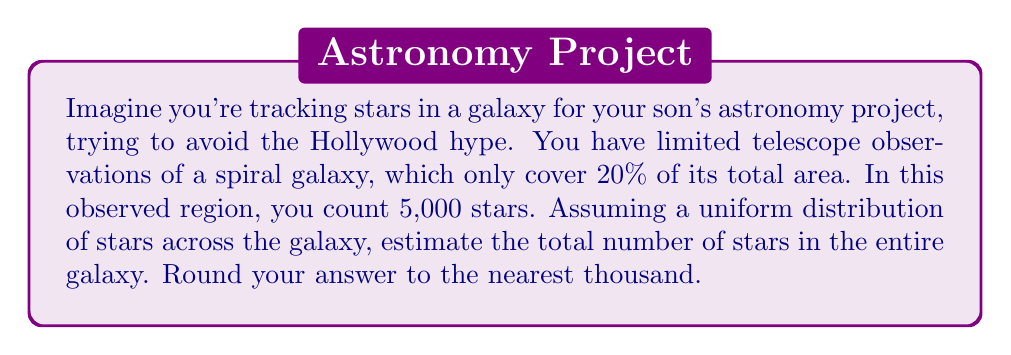Can you solve this math problem? Let's approach this step-by-step:

1) First, we need to understand what we're given:
   - Observed area: 20% of the galaxy
   - Number of stars in observed area: 5,000

2) We're assuming a uniform distribution of stars across the galaxy. This means the density of stars should be consistent throughout.

3) To find the total number of stars, we need to set up a proportion:

   $$\frac{\text{Observed stars}}{\text{Observed area}} = \frac{\text{Total stars}}{\text{Total area}}$$

4) We know the observed stars (5,000) and the observed area (20% or 0.2). Let's call the total number of stars x:

   $$\frac{5,000}{0.2} = \frac{x}{1}$$

5) Cross multiply:

   $$5,000 \cdot 1 = 0.2x$$

6) Solve for x:

   $$x = \frac{5,000}{0.2} = 25,000$$

7) Round to the nearest thousand:

   25,000 stars

This method is an example of solving an inverse problem, where we use limited data to estimate a larger, unknown quantity.
Answer: 25,000 stars 